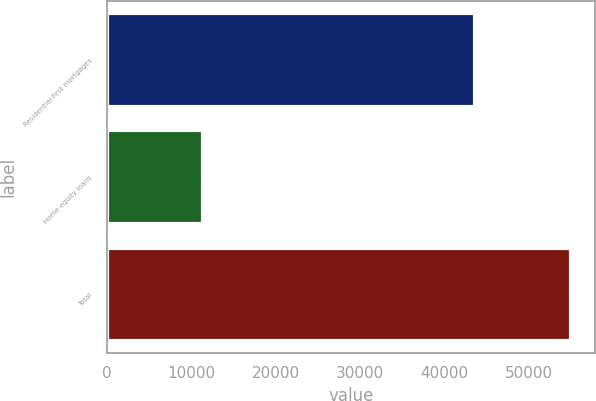Convert chart to OTSL. <chart><loc_0><loc_0><loc_500><loc_500><bar_chart><fcel>Residential first mortgages<fcel>Home equity loans<fcel>Total<nl><fcel>43626<fcel>11403<fcel>55029<nl></chart> 